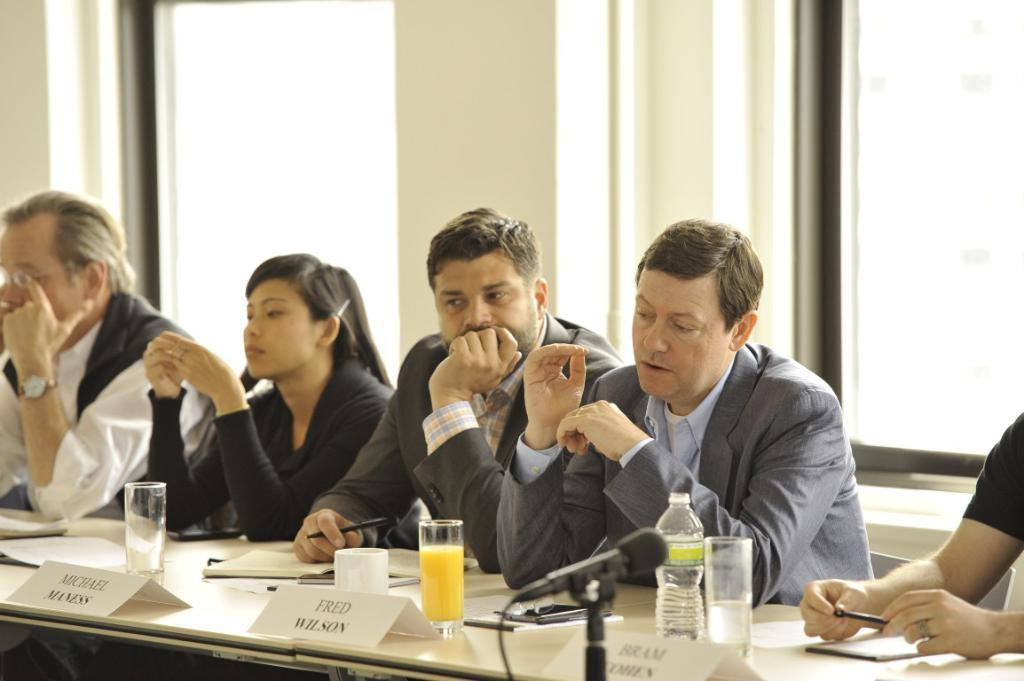How many people are in the image? There is a group of persons in the image. What are the persons doing in the image? The persons are sitting on chairs. What can be seen on the table in the image? There are water glasses, bottles, and microphones on the table. What is the father doing with the girl in the image? There is no father or girl present in the image. The image features a group of persons sitting on chairs, and there is no mention of a father or girl. 